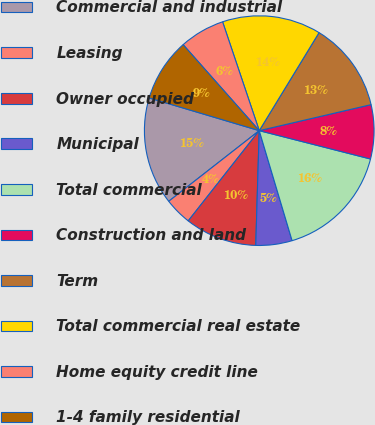<chart> <loc_0><loc_0><loc_500><loc_500><pie_chart><fcel>Commercial and industrial<fcel>Leasing<fcel>Owner occupied<fcel>Municipal<fcel>Total commercial<fcel>Construction and land<fcel>Term<fcel>Total commercial real estate<fcel>Home equity credit line<fcel>1-4 family residential<nl><fcel>15.15%<fcel>3.84%<fcel>10.13%<fcel>5.1%<fcel>16.41%<fcel>7.61%<fcel>12.64%<fcel>13.89%<fcel>6.36%<fcel>8.87%<nl></chart> 